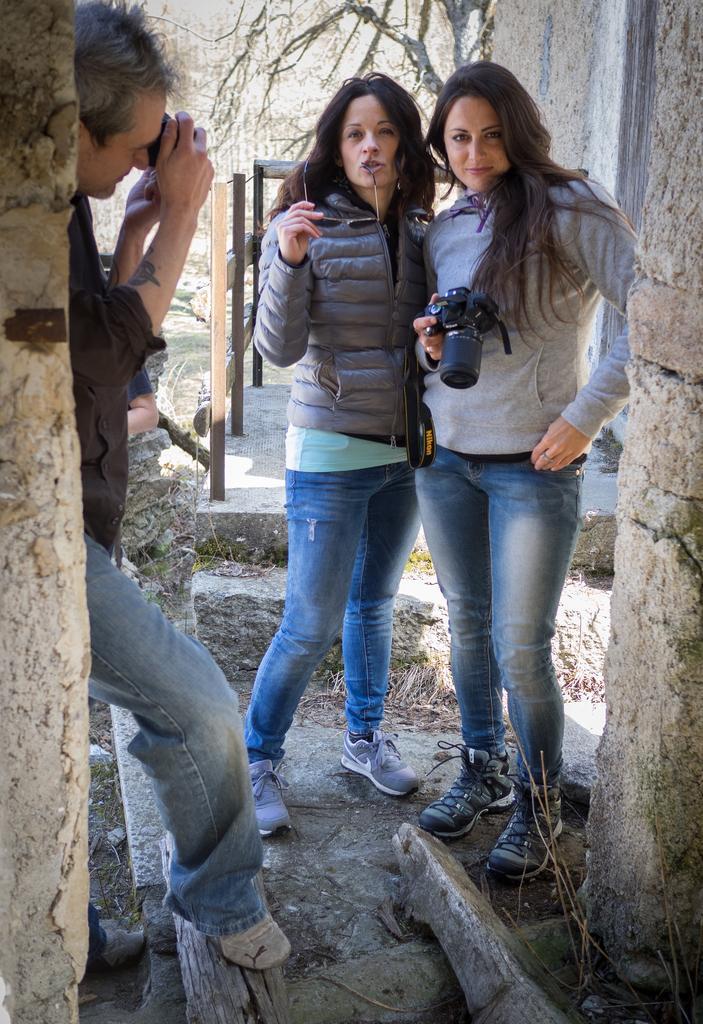Can you describe this image briefly? In this image we can see some people standing. In that a man and a woman are holding the cameras and the other is holding the glasses. We can also see the walls and some wooden logs on the ground. On the backside we can see the wooden fence and a group of trees. 